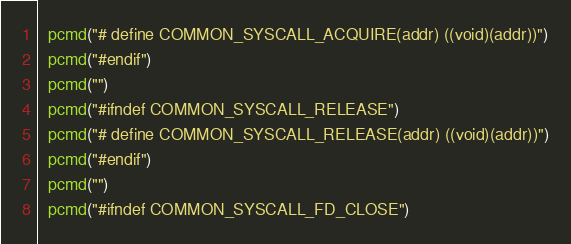Convert code to text. <code><loc_0><loc_0><loc_500><loc_500><_Awk_>  pcmd("# define COMMON_SYSCALL_ACQUIRE(addr) ((void)(addr))")
  pcmd("#endif")
  pcmd("")
  pcmd("#ifndef COMMON_SYSCALL_RELEASE")
  pcmd("# define COMMON_SYSCALL_RELEASE(addr) ((void)(addr))")
  pcmd("#endif")
  pcmd("")
  pcmd("#ifndef COMMON_SYSCALL_FD_CLOSE")</code> 